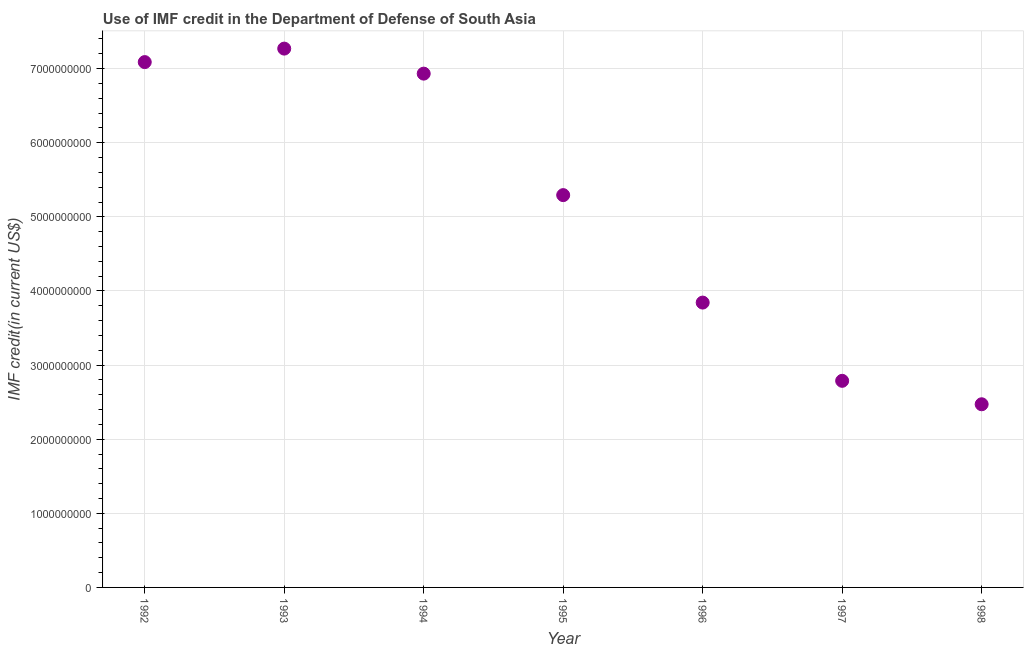What is the use of imf credit in dod in 1992?
Your response must be concise. 7.09e+09. Across all years, what is the maximum use of imf credit in dod?
Make the answer very short. 7.27e+09. Across all years, what is the minimum use of imf credit in dod?
Make the answer very short. 2.47e+09. What is the sum of the use of imf credit in dod?
Provide a short and direct response. 3.57e+1. What is the difference between the use of imf credit in dod in 1992 and 1995?
Ensure brevity in your answer.  1.79e+09. What is the average use of imf credit in dod per year?
Offer a terse response. 5.10e+09. What is the median use of imf credit in dod?
Provide a short and direct response. 5.29e+09. In how many years, is the use of imf credit in dod greater than 4400000000 US$?
Keep it short and to the point. 4. Do a majority of the years between 1992 and 1998 (inclusive) have use of imf credit in dod greater than 5000000000 US$?
Your response must be concise. Yes. What is the ratio of the use of imf credit in dod in 1995 to that in 1997?
Your answer should be compact. 1.9. Is the difference between the use of imf credit in dod in 1996 and 1997 greater than the difference between any two years?
Offer a terse response. No. What is the difference between the highest and the second highest use of imf credit in dod?
Your answer should be compact. 1.82e+08. What is the difference between the highest and the lowest use of imf credit in dod?
Offer a terse response. 4.80e+09. Does the use of imf credit in dod monotonically increase over the years?
Keep it short and to the point. No. How many dotlines are there?
Offer a very short reply. 1. What is the difference between two consecutive major ticks on the Y-axis?
Offer a very short reply. 1.00e+09. Are the values on the major ticks of Y-axis written in scientific E-notation?
Offer a very short reply. No. What is the title of the graph?
Give a very brief answer. Use of IMF credit in the Department of Defense of South Asia. What is the label or title of the Y-axis?
Keep it short and to the point. IMF credit(in current US$). What is the IMF credit(in current US$) in 1992?
Provide a short and direct response. 7.09e+09. What is the IMF credit(in current US$) in 1993?
Provide a short and direct response. 7.27e+09. What is the IMF credit(in current US$) in 1994?
Keep it short and to the point. 6.93e+09. What is the IMF credit(in current US$) in 1995?
Provide a succinct answer. 5.29e+09. What is the IMF credit(in current US$) in 1996?
Offer a very short reply. 3.84e+09. What is the IMF credit(in current US$) in 1997?
Keep it short and to the point. 2.79e+09. What is the IMF credit(in current US$) in 1998?
Give a very brief answer. 2.47e+09. What is the difference between the IMF credit(in current US$) in 1992 and 1993?
Ensure brevity in your answer.  -1.82e+08. What is the difference between the IMF credit(in current US$) in 1992 and 1994?
Make the answer very short. 1.56e+08. What is the difference between the IMF credit(in current US$) in 1992 and 1995?
Keep it short and to the point. 1.79e+09. What is the difference between the IMF credit(in current US$) in 1992 and 1996?
Keep it short and to the point. 3.24e+09. What is the difference between the IMF credit(in current US$) in 1992 and 1997?
Make the answer very short. 4.30e+09. What is the difference between the IMF credit(in current US$) in 1992 and 1998?
Your answer should be very brief. 4.62e+09. What is the difference between the IMF credit(in current US$) in 1993 and 1994?
Your answer should be very brief. 3.38e+08. What is the difference between the IMF credit(in current US$) in 1993 and 1995?
Give a very brief answer. 1.98e+09. What is the difference between the IMF credit(in current US$) in 1993 and 1996?
Keep it short and to the point. 3.43e+09. What is the difference between the IMF credit(in current US$) in 1993 and 1997?
Make the answer very short. 4.48e+09. What is the difference between the IMF credit(in current US$) in 1993 and 1998?
Provide a succinct answer. 4.80e+09. What is the difference between the IMF credit(in current US$) in 1994 and 1995?
Keep it short and to the point. 1.64e+09. What is the difference between the IMF credit(in current US$) in 1994 and 1996?
Offer a terse response. 3.09e+09. What is the difference between the IMF credit(in current US$) in 1994 and 1997?
Give a very brief answer. 4.14e+09. What is the difference between the IMF credit(in current US$) in 1994 and 1998?
Your answer should be very brief. 4.46e+09. What is the difference between the IMF credit(in current US$) in 1995 and 1996?
Offer a very short reply. 1.45e+09. What is the difference between the IMF credit(in current US$) in 1995 and 1997?
Give a very brief answer. 2.51e+09. What is the difference between the IMF credit(in current US$) in 1995 and 1998?
Your response must be concise. 2.82e+09. What is the difference between the IMF credit(in current US$) in 1996 and 1997?
Offer a very short reply. 1.06e+09. What is the difference between the IMF credit(in current US$) in 1996 and 1998?
Offer a terse response. 1.37e+09. What is the difference between the IMF credit(in current US$) in 1997 and 1998?
Provide a succinct answer. 3.16e+08. What is the ratio of the IMF credit(in current US$) in 1992 to that in 1993?
Provide a short and direct response. 0.97. What is the ratio of the IMF credit(in current US$) in 1992 to that in 1995?
Your answer should be compact. 1.34. What is the ratio of the IMF credit(in current US$) in 1992 to that in 1996?
Your answer should be very brief. 1.84. What is the ratio of the IMF credit(in current US$) in 1992 to that in 1997?
Make the answer very short. 2.54. What is the ratio of the IMF credit(in current US$) in 1992 to that in 1998?
Your answer should be compact. 2.87. What is the ratio of the IMF credit(in current US$) in 1993 to that in 1994?
Provide a succinct answer. 1.05. What is the ratio of the IMF credit(in current US$) in 1993 to that in 1995?
Make the answer very short. 1.37. What is the ratio of the IMF credit(in current US$) in 1993 to that in 1996?
Your answer should be very brief. 1.89. What is the ratio of the IMF credit(in current US$) in 1993 to that in 1997?
Provide a short and direct response. 2.61. What is the ratio of the IMF credit(in current US$) in 1993 to that in 1998?
Ensure brevity in your answer.  2.94. What is the ratio of the IMF credit(in current US$) in 1994 to that in 1995?
Offer a terse response. 1.31. What is the ratio of the IMF credit(in current US$) in 1994 to that in 1996?
Your answer should be compact. 1.8. What is the ratio of the IMF credit(in current US$) in 1994 to that in 1997?
Your response must be concise. 2.49. What is the ratio of the IMF credit(in current US$) in 1994 to that in 1998?
Ensure brevity in your answer.  2.81. What is the ratio of the IMF credit(in current US$) in 1995 to that in 1996?
Give a very brief answer. 1.38. What is the ratio of the IMF credit(in current US$) in 1995 to that in 1997?
Your answer should be compact. 1.9. What is the ratio of the IMF credit(in current US$) in 1995 to that in 1998?
Your response must be concise. 2.14. What is the ratio of the IMF credit(in current US$) in 1996 to that in 1997?
Provide a short and direct response. 1.38. What is the ratio of the IMF credit(in current US$) in 1996 to that in 1998?
Offer a very short reply. 1.55. What is the ratio of the IMF credit(in current US$) in 1997 to that in 1998?
Give a very brief answer. 1.13. 